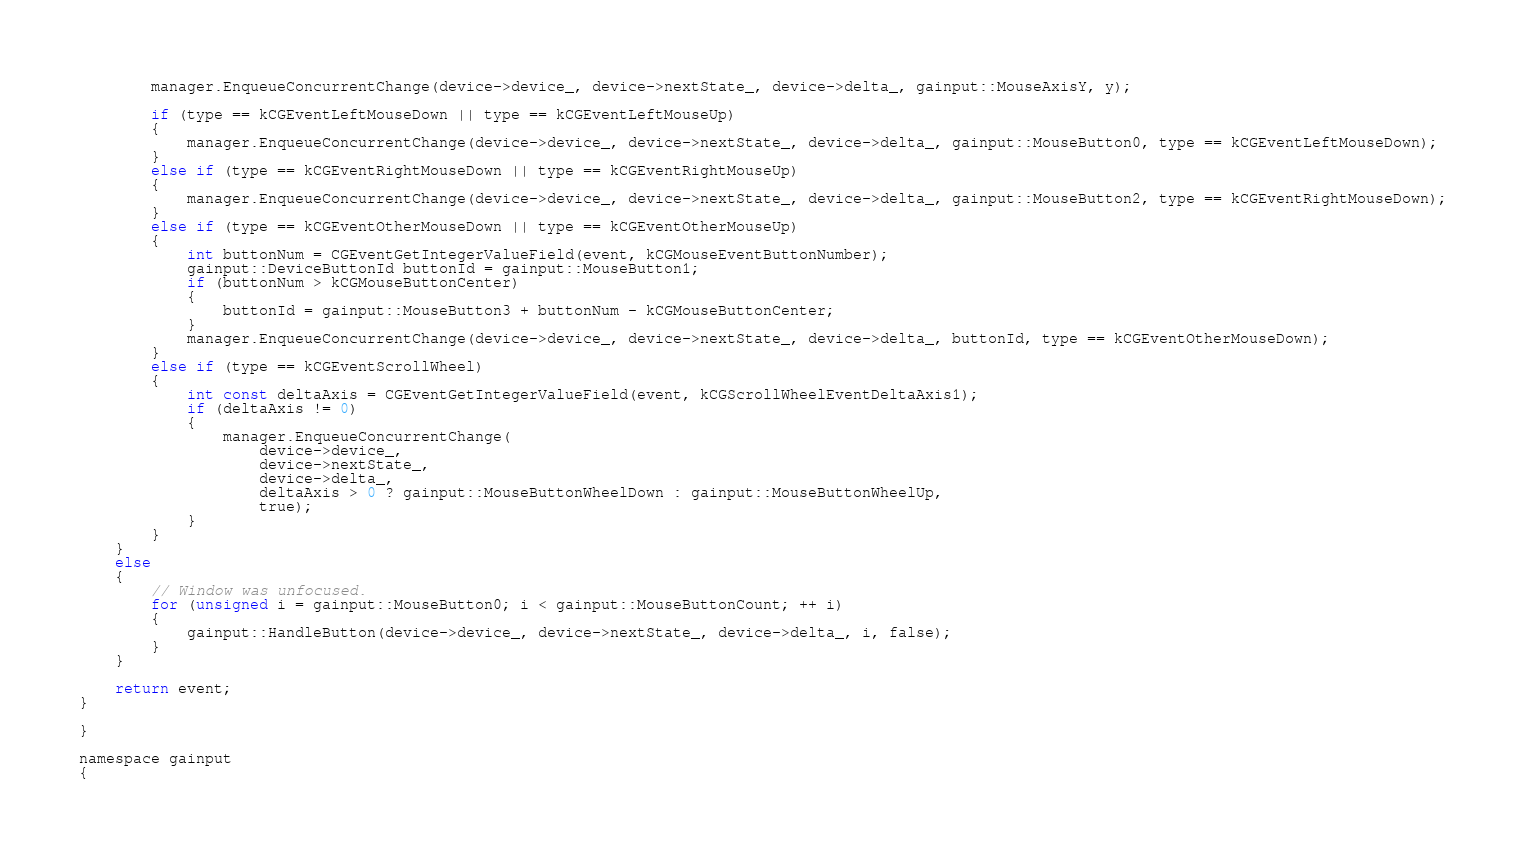<code> <loc_0><loc_0><loc_500><loc_500><_ObjectiveC_>		manager.EnqueueConcurrentChange(device->device_, device->nextState_, device->delta_, gainput::MouseAxisY, y);

		if (type == kCGEventLeftMouseDown || type == kCGEventLeftMouseUp)
		{
			manager.EnqueueConcurrentChange(device->device_, device->nextState_, device->delta_, gainput::MouseButton0, type == kCGEventLeftMouseDown);
		}
		else if (type == kCGEventRightMouseDown || type == kCGEventRightMouseUp)
		{
			manager.EnqueueConcurrentChange(device->device_, device->nextState_, device->delta_, gainput::MouseButton2, type == kCGEventRightMouseDown);
		}
		else if (type == kCGEventOtherMouseDown || type == kCGEventOtherMouseUp)
		{
			int buttonNum = CGEventGetIntegerValueField(event, kCGMouseEventButtonNumber);
			gainput::DeviceButtonId buttonId = gainput::MouseButton1;
			if (buttonNum > kCGMouseButtonCenter)
			{
				buttonId = gainput::MouseButton3 + buttonNum - kCGMouseButtonCenter;
			}
			manager.EnqueueConcurrentChange(device->device_, device->nextState_, device->delta_, buttonId, type == kCGEventOtherMouseDown);
		}
		else if (type == kCGEventScrollWheel)
		{
			int const deltaAxis = CGEventGetIntegerValueField(event, kCGScrollWheelEventDeltaAxis1);
            if (deltaAxis != 0)
            {
                manager.EnqueueConcurrentChange(
                    device->device_,
                    device->nextState_,
                    device->delta_,
                    deltaAxis > 0 ? gainput::MouseButtonWheelDown : gainput::MouseButtonWheelUp,
                    true);
            }
		}
	}
    else
    {
        // Window was unfocused.
        for (unsigned i = gainput::MouseButton0; i < gainput::MouseButtonCount; ++ i)
        {
            gainput::HandleButton(device->device_, device->nextState_, device->delta_, i, false);
        }
    }

	return event;
}

}

namespace gainput
{
</code> 